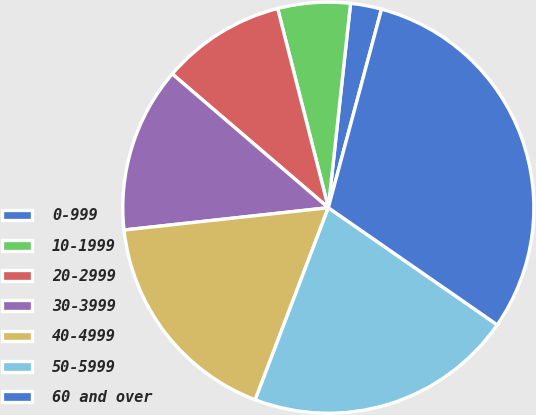Convert chart to OTSL. <chart><loc_0><loc_0><loc_500><loc_500><pie_chart><fcel>0-999<fcel>10-1999<fcel>20-2999<fcel>30-3999<fcel>40-4999<fcel>50-5999<fcel>60 and over<nl><fcel>2.44%<fcel>5.69%<fcel>9.76%<fcel>13.01%<fcel>17.48%<fcel>21.14%<fcel>30.49%<nl></chart> 